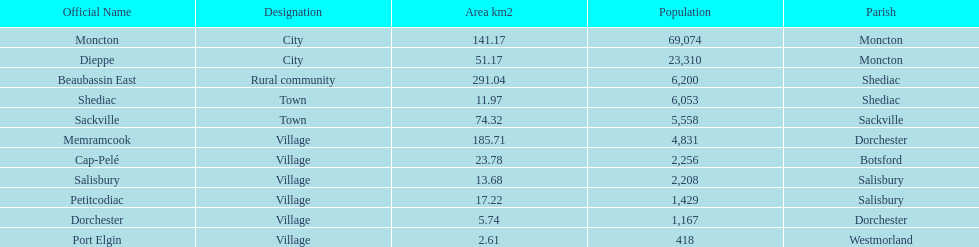Which city has the minimum area? Port Elgin. 